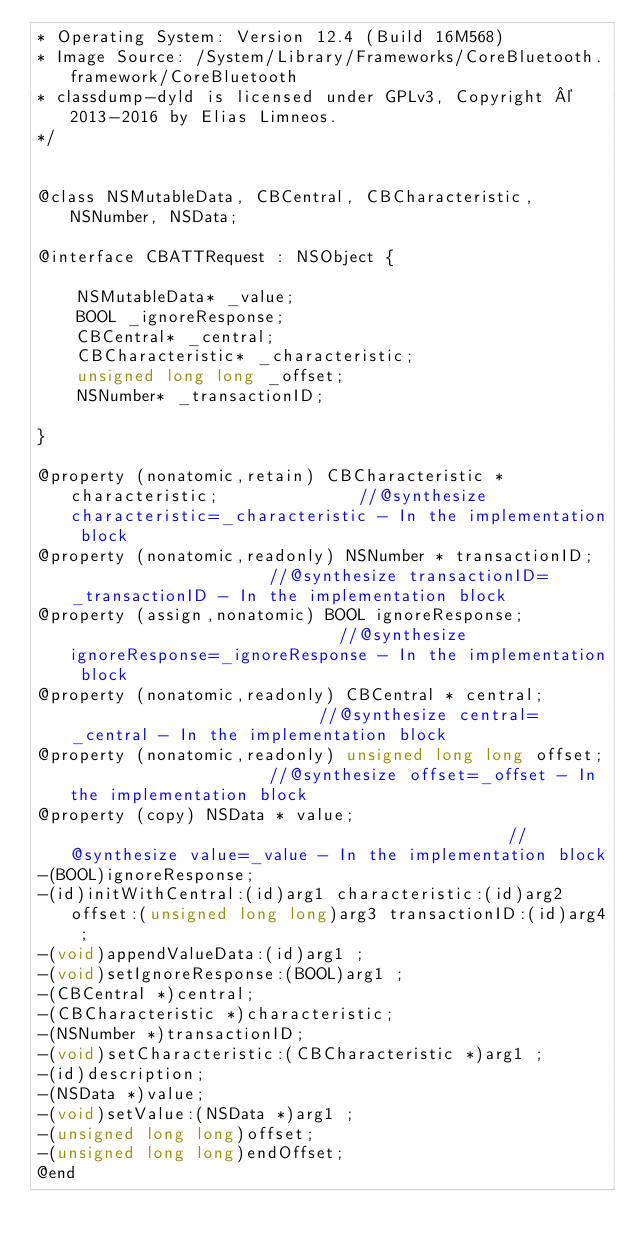<code> <loc_0><loc_0><loc_500><loc_500><_C_>* Operating System: Version 12.4 (Build 16M568)
* Image Source: /System/Library/Frameworks/CoreBluetooth.framework/CoreBluetooth
* classdump-dyld is licensed under GPLv3, Copyright © 2013-2016 by Elias Limneos.
*/


@class NSMutableData, CBCentral, CBCharacteristic, NSNumber, NSData;

@interface CBATTRequest : NSObject {

	NSMutableData* _value;
	BOOL _ignoreResponse;
	CBCentral* _central;
	CBCharacteristic* _characteristic;
	unsigned long long _offset;
	NSNumber* _transactionID;

}

@property (nonatomic,retain) CBCharacteristic * characteristic;              //@synthesize characteristic=_characteristic - In the implementation block
@property (nonatomic,readonly) NSNumber * transactionID;                     //@synthesize transactionID=_transactionID - In the implementation block
@property (assign,nonatomic) BOOL ignoreResponse;                            //@synthesize ignoreResponse=_ignoreResponse - In the implementation block
@property (nonatomic,readonly) CBCentral * central;                          //@synthesize central=_central - In the implementation block
@property (nonatomic,readonly) unsigned long long offset;                    //@synthesize offset=_offset - In the implementation block
@property (copy) NSData * value;                                             //@synthesize value=_value - In the implementation block
-(BOOL)ignoreResponse;
-(id)initWithCentral:(id)arg1 characteristic:(id)arg2 offset:(unsigned long long)arg3 transactionID:(id)arg4 ;
-(void)appendValueData:(id)arg1 ;
-(void)setIgnoreResponse:(BOOL)arg1 ;
-(CBCentral *)central;
-(CBCharacteristic *)characteristic;
-(NSNumber *)transactionID;
-(void)setCharacteristic:(CBCharacteristic *)arg1 ;
-(id)description;
-(NSData *)value;
-(void)setValue:(NSData *)arg1 ;
-(unsigned long long)offset;
-(unsigned long long)endOffset;
@end

</code> 